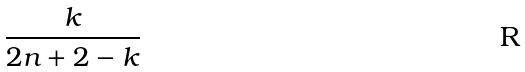Convert formula to latex. <formula><loc_0><loc_0><loc_500><loc_500>\frac { k } { 2 n + 2 - k }</formula> 